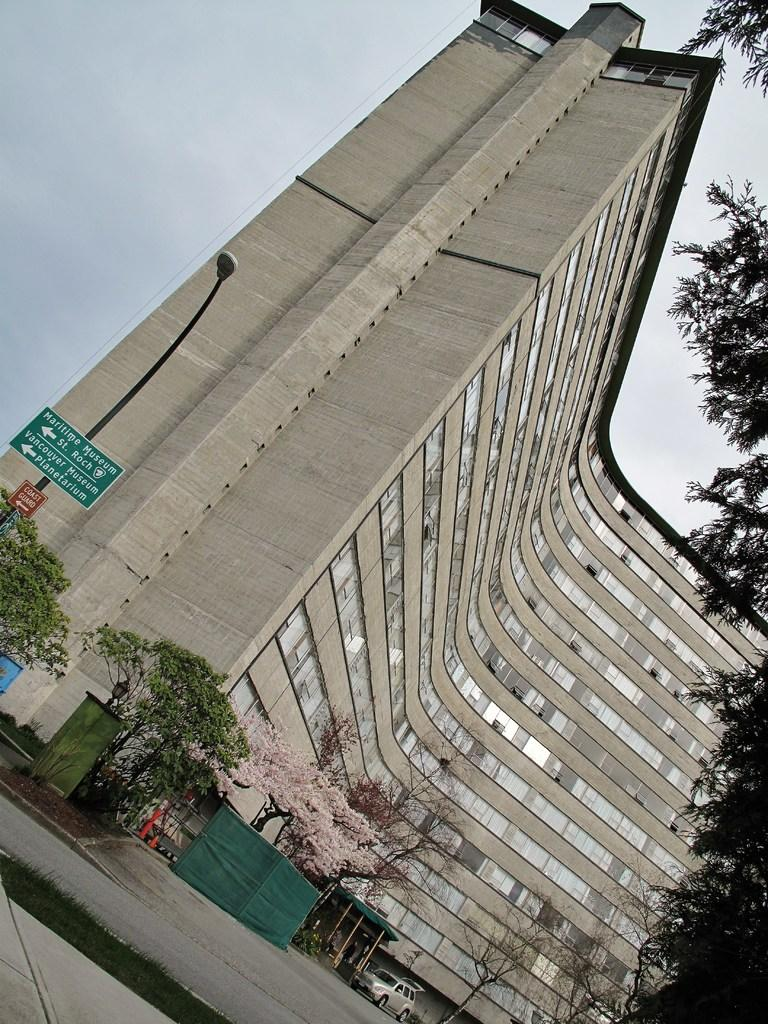What is located in the center of the image? In the center of the image, there are trees, tents, poles, sign boards, a fence, a road, and a vehicle. Can you describe the background of the image? The background of the image includes the sky, clouds, buildings, and trees. What type of structure is visible in the center of the image? The tents and poles in the center of the image suggest that there might be a temporary structure or campsite. What is the condition of the sky in the background? The sky in the background is visible, and there are clouds present. What type of cushion is being used by the band in the image? There is no band or cushion present in the image. What sound does the horn make in the image? There is no horn present in the image. 